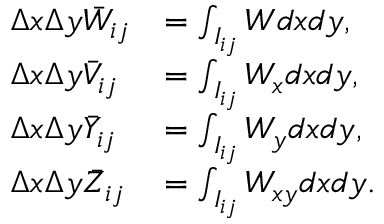<formula> <loc_0><loc_0><loc_500><loc_500>\begin{array} { l l l l } { \Delta x \Delta y \ B a r W _ { i j } } & { = \int _ { I _ { i j } } W d x d y , } \\ { \Delta x \Delta y \ B a r V _ { i j } } & { = \int _ { I _ { i j } } W _ { x } d x d y , } \\ { \Delta x \Delta y \ B a r Y _ { i j } } & { = \int _ { I _ { i j } } W _ { y } d x d y , } \\ { \Delta x \Delta y \ B a r Z _ { i j } } & { = \int _ { I _ { i j } } W _ { x y } d x d y . } \end{array}</formula> 